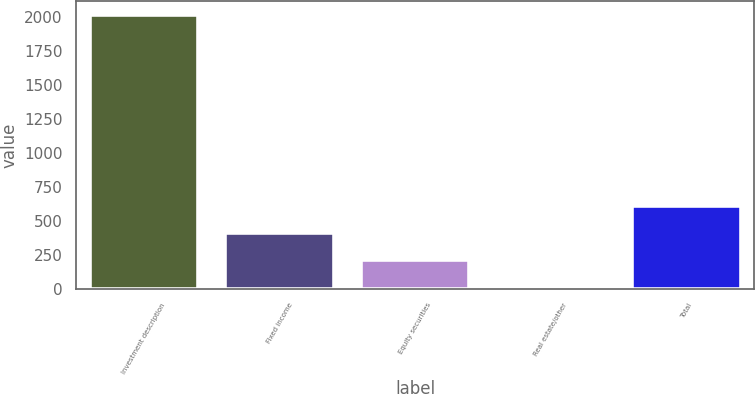Convert chart. <chart><loc_0><loc_0><loc_500><loc_500><bar_chart><fcel>Investment description<fcel>Fixed income<fcel>Equity securities<fcel>Real estate/other<fcel>Total<nl><fcel>2015<fcel>413.08<fcel>212.84<fcel>12.6<fcel>613.32<nl></chart> 